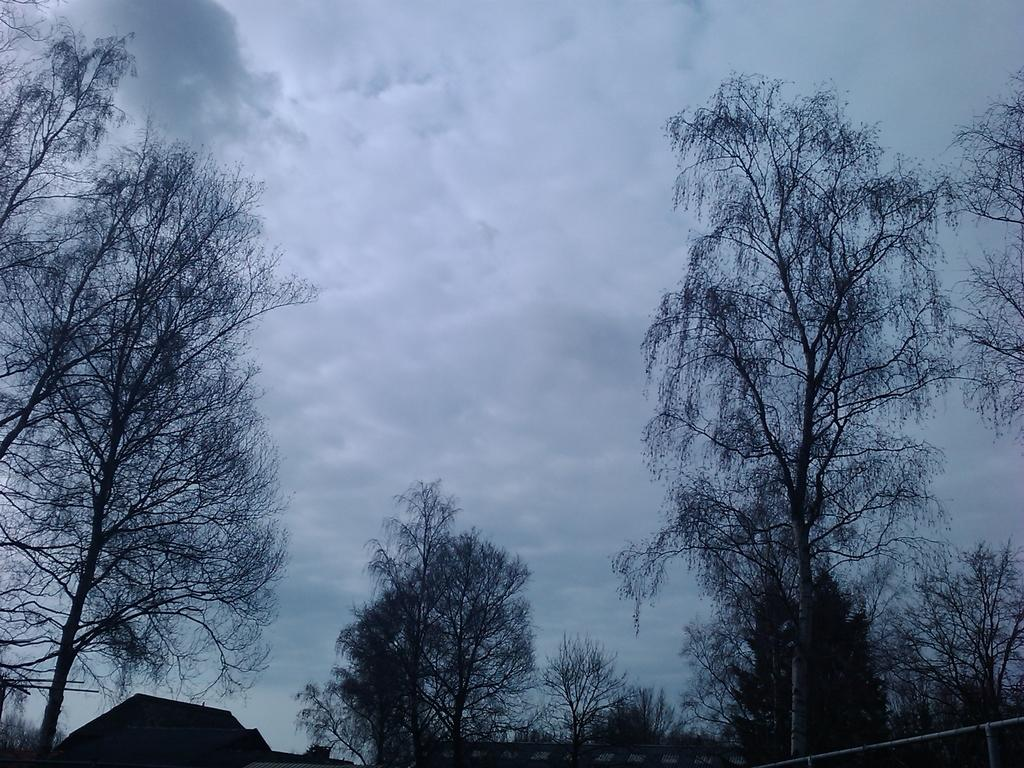What type of vegetation can be seen in the image? There are trees in the image. What can be seen in the sky in the image? There are clouds in the sky in the image. How many dimes are scattered on the ground in the image? There are no dimes present in the image; it features trees and clouds. What type of dirt is visible on the ground in the image? There is no dirt visible in the image, as it only features trees and clouds. 